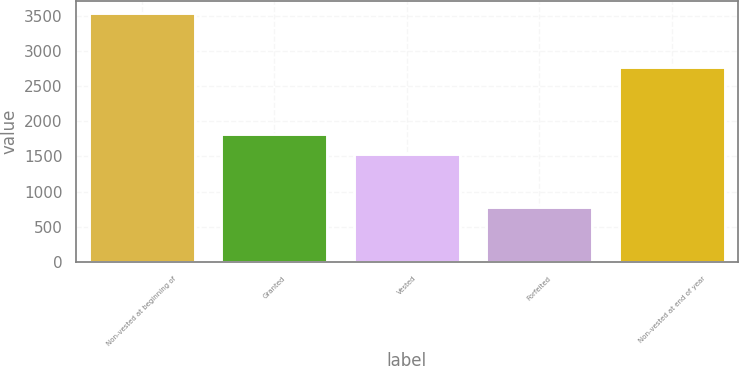Convert chart. <chart><loc_0><loc_0><loc_500><loc_500><bar_chart><fcel>Non-vested at beginning of<fcel>Granted<fcel>Vested<fcel>Forfeited<fcel>Non-vested at end of year<nl><fcel>3539<fcel>1817.4<fcel>1541<fcel>775<fcel>2775<nl></chart> 